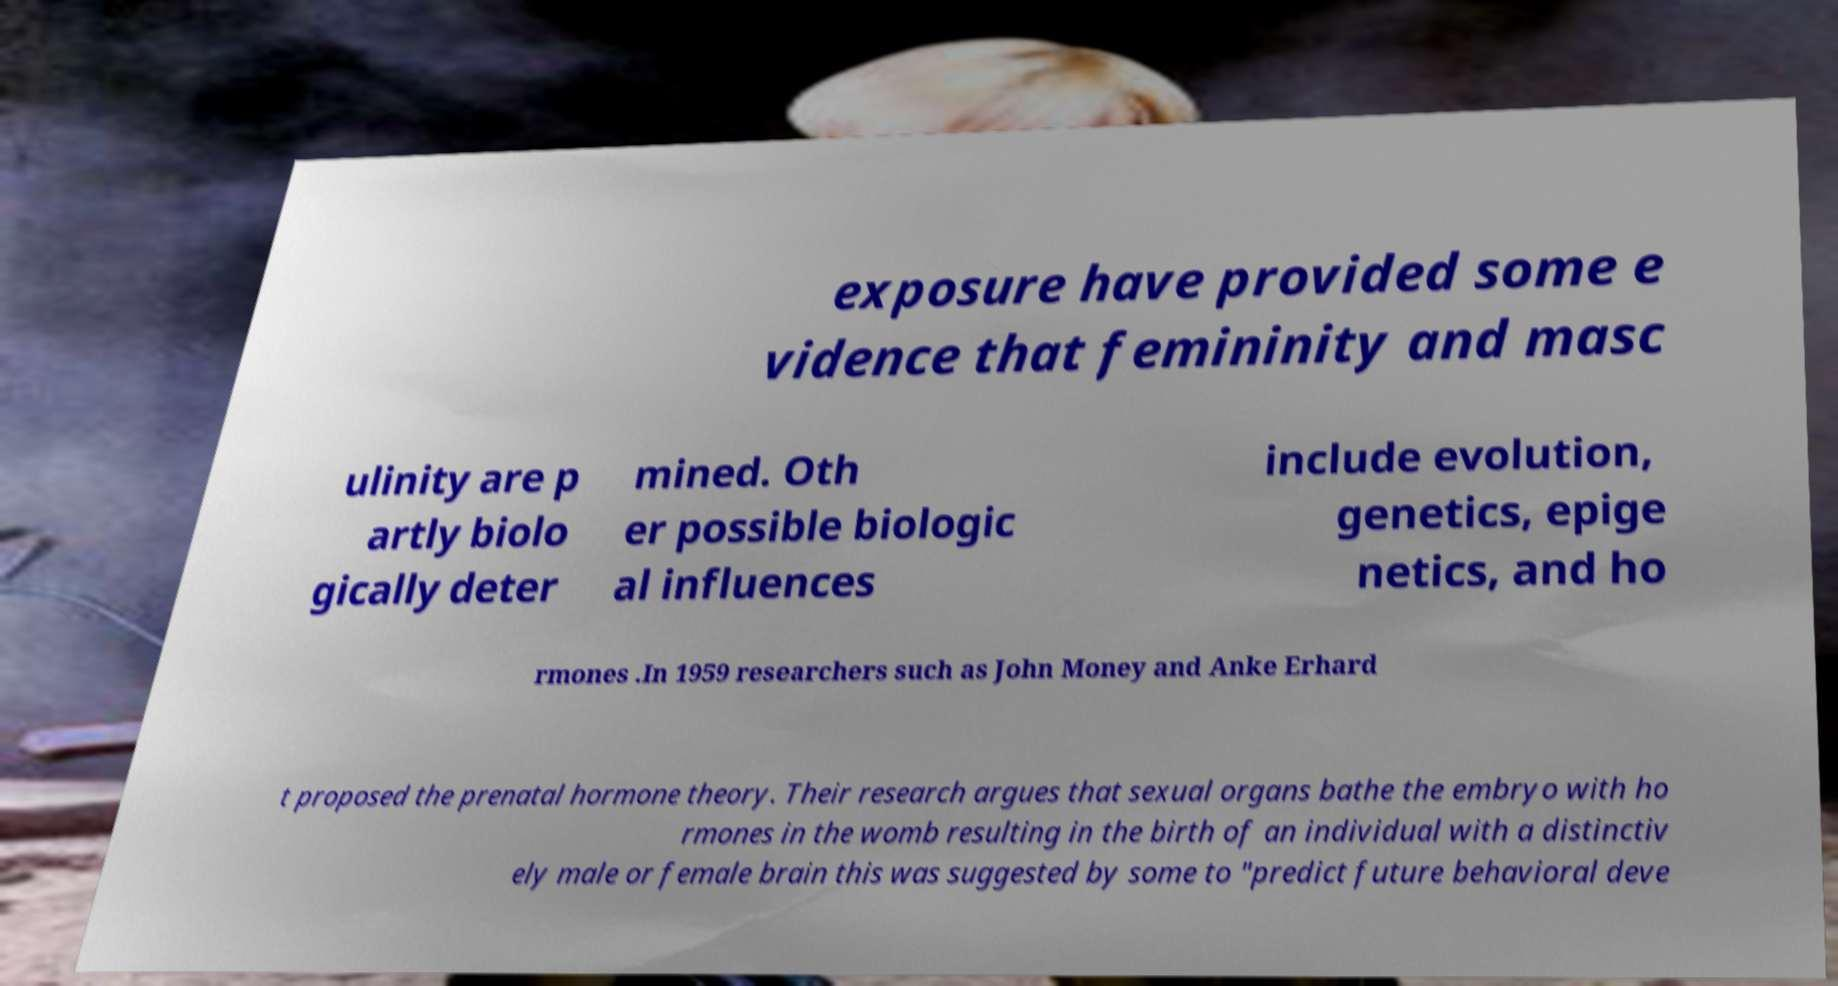Please read and relay the text visible in this image. What does it say? exposure have provided some e vidence that femininity and masc ulinity are p artly biolo gically deter mined. Oth er possible biologic al influences include evolution, genetics, epige netics, and ho rmones .In 1959 researchers such as John Money and Anke Erhard t proposed the prenatal hormone theory. Their research argues that sexual organs bathe the embryo with ho rmones in the womb resulting in the birth of an individual with a distinctiv ely male or female brain this was suggested by some to "predict future behavioral deve 